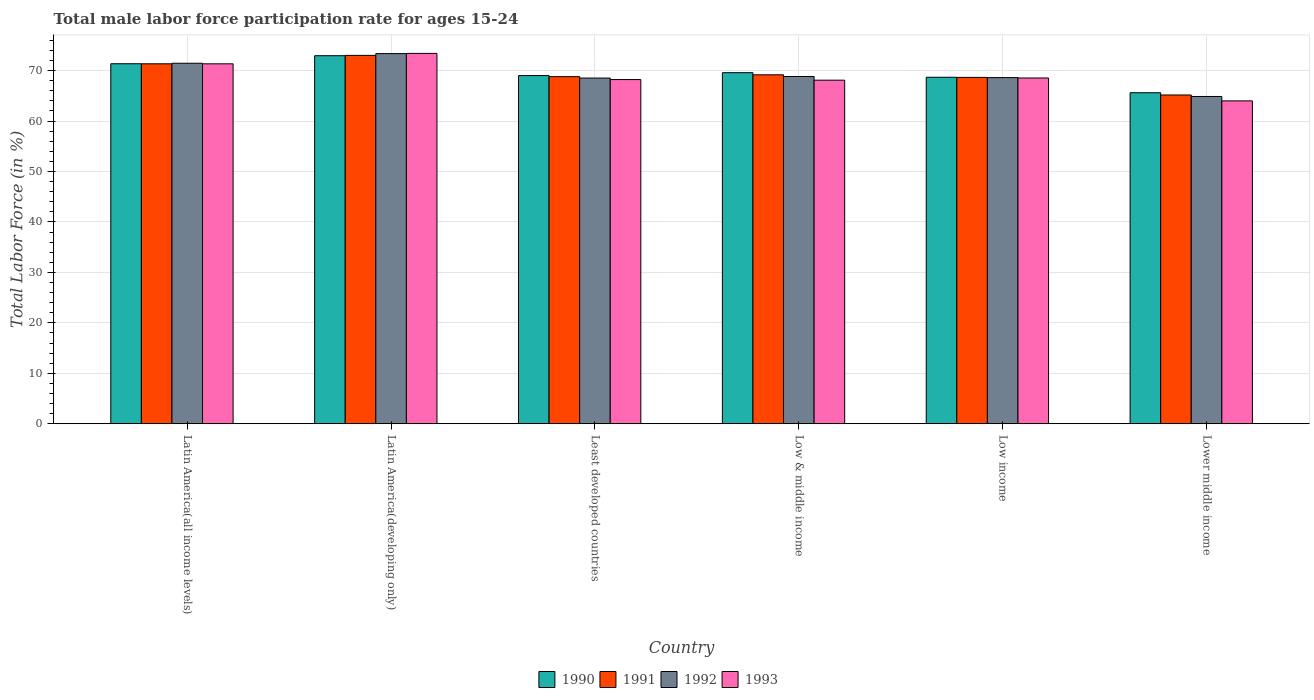How many different coloured bars are there?
Provide a succinct answer. 4. How many bars are there on the 1st tick from the right?
Give a very brief answer. 4. What is the label of the 6th group of bars from the left?
Offer a terse response. Lower middle income. In how many cases, is the number of bars for a given country not equal to the number of legend labels?
Give a very brief answer. 0. What is the male labor force participation rate in 1991 in Least developed countries?
Provide a succinct answer. 68.8. Across all countries, what is the maximum male labor force participation rate in 1992?
Provide a short and direct response. 73.38. Across all countries, what is the minimum male labor force participation rate in 1991?
Ensure brevity in your answer.  65.17. In which country was the male labor force participation rate in 1992 maximum?
Make the answer very short. Latin America(developing only). In which country was the male labor force participation rate in 1992 minimum?
Provide a succinct answer. Lower middle income. What is the total male labor force participation rate in 1992 in the graph?
Ensure brevity in your answer.  415.69. What is the difference between the male labor force participation rate in 1990 in Low & middle income and that in Low income?
Provide a succinct answer. 0.91. What is the difference between the male labor force participation rate in 1991 in Latin America(developing only) and the male labor force participation rate in 1992 in Lower middle income?
Give a very brief answer. 8.15. What is the average male labor force participation rate in 1992 per country?
Ensure brevity in your answer.  69.28. What is the difference between the male labor force participation rate of/in 1992 and male labor force participation rate of/in 1990 in Latin America(developing only)?
Your answer should be compact. 0.42. What is the ratio of the male labor force participation rate in 1993 in Latin America(all income levels) to that in Least developed countries?
Your response must be concise. 1.05. Is the male labor force participation rate in 1991 in Least developed countries less than that in Lower middle income?
Your response must be concise. No. What is the difference between the highest and the second highest male labor force participation rate in 1990?
Make the answer very short. 3.36. What is the difference between the highest and the lowest male labor force participation rate in 1990?
Ensure brevity in your answer.  7.34. Is the sum of the male labor force participation rate in 1992 in Latin America(all income levels) and Low & middle income greater than the maximum male labor force participation rate in 1993 across all countries?
Your response must be concise. Yes. What does the 2nd bar from the left in Low income represents?
Offer a terse response. 1991. How many bars are there?
Ensure brevity in your answer.  24. Are the values on the major ticks of Y-axis written in scientific E-notation?
Your answer should be very brief. No. Does the graph contain grids?
Your answer should be compact. Yes. How are the legend labels stacked?
Your response must be concise. Horizontal. What is the title of the graph?
Provide a succinct answer. Total male labor force participation rate for ages 15-24. Does "1995" appear as one of the legend labels in the graph?
Give a very brief answer. No. What is the label or title of the X-axis?
Keep it short and to the point. Country. What is the label or title of the Y-axis?
Offer a terse response. Total Labor Force (in %). What is the Total Labor Force (in %) in 1990 in Latin America(all income levels)?
Your response must be concise. 71.36. What is the Total Labor Force (in %) in 1991 in Latin America(all income levels)?
Your answer should be compact. 71.35. What is the Total Labor Force (in %) in 1992 in Latin America(all income levels)?
Provide a succinct answer. 71.46. What is the Total Labor Force (in %) in 1993 in Latin America(all income levels)?
Keep it short and to the point. 71.35. What is the Total Labor Force (in %) of 1990 in Latin America(developing only)?
Ensure brevity in your answer.  72.96. What is the Total Labor Force (in %) in 1991 in Latin America(developing only)?
Offer a very short reply. 73.02. What is the Total Labor Force (in %) in 1992 in Latin America(developing only)?
Your answer should be very brief. 73.38. What is the Total Labor Force (in %) in 1993 in Latin America(developing only)?
Offer a terse response. 73.42. What is the Total Labor Force (in %) of 1990 in Least developed countries?
Your answer should be compact. 69.02. What is the Total Labor Force (in %) in 1991 in Least developed countries?
Make the answer very short. 68.8. What is the Total Labor Force (in %) of 1992 in Least developed countries?
Your answer should be compact. 68.53. What is the Total Labor Force (in %) in 1993 in Least developed countries?
Offer a very short reply. 68.23. What is the Total Labor Force (in %) in 1990 in Low & middle income?
Your answer should be compact. 69.59. What is the Total Labor Force (in %) in 1991 in Low & middle income?
Your answer should be compact. 69.17. What is the Total Labor Force (in %) in 1992 in Low & middle income?
Keep it short and to the point. 68.83. What is the Total Labor Force (in %) of 1993 in Low & middle income?
Provide a short and direct response. 68.11. What is the Total Labor Force (in %) in 1990 in Low income?
Provide a succinct answer. 68.69. What is the Total Labor Force (in %) of 1991 in Low income?
Make the answer very short. 68.66. What is the Total Labor Force (in %) of 1992 in Low income?
Offer a very short reply. 68.62. What is the Total Labor Force (in %) in 1993 in Low income?
Offer a very short reply. 68.54. What is the Total Labor Force (in %) of 1990 in Lower middle income?
Keep it short and to the point. 65.62. What is the Total Labor Force (in %) in 1991 in Lower middle income?
Provide a succinct answer. 65.17. What is the Total Labor Force (in %) in 1992 in Lower middle income?
Make the answer very short. 64.87. What is the Total Labor Force (in %) in 1993 in Lower middle income?
Offer a terse response. 64. Across all countries, what is the maximum Total Labor Force (in %) in 1990?
Ensure brevity in your answer.  72.96. Across all countries, what is the maximum Total Labor Force (in %) of 1991?
Your response must be concise. 73.02. Across all countries, what is the maximum Total Labor Force (in %) in 1992?
Your response must be concise. 73.38. Across all countries, what is the maximum Total Labor Force (in %) of 1993?
Make the answer very short. 73.42. Across all countries, what is the minimum Total Labor Force (in %) of 1990?
Provide a succinct answer. 65.62. Across all countries, what is the minimum Total Labor Force (in %) of 1991?
Provide a short and direct response. 65.17. Across all countries, what is the minimum Total Labor Force (in %) of 1992?
Make the answer very short. 64.87. Across all countries, what is the minimum Total Labor Force (in %) of 1993?
Your response must be concise. 64. What is the total Total Labor Force (in %) of 1990 in the graph?
Keep it short and to the point. 417.24. What is the total Total Labor Force (in %) in 1991 in the graph?
Your response must be concise. 416.18. What is the total Total Labor Force (in %) in 1992 in the graph?
Your answer should be compact. 415.69. What is the total Total Labor Force (in %) of 1993 in the graph?
Your response must be concise. 413.64. What is the difference between the Total Labor Force (in %) of 1990 in Latin America(all income levels) and that in Latin America(developing only)?
Make the answer very short. -1.59. What is the difference between the Total Labor Force (in %) of 1991 in Latin America(all income levels) and that in Latin America(developing only)?
Your answer should be very brief. -1.67. What is the difference between the Total Labor Force (in %) in 1992 in Latin America(all income levels) and that in Latin America(developing only)?
Offer a very short reply. -1.91. What is the difference between the Total Labor Force (in %) in 1993 in Latin America(all income levels) and that in Latin America(developing only)?
Offer a very short reply. -2.07. What is the difference between the Total Labor Force (in %) in 1990 in Latin America(all income levels) and that in Least developed countries?
Ensure brevity in your answer.  2.35. What is the difference between the Total Labor Force (in %) of 1991 in Latin America(all income levels) and that in Least developed countries?
Your answer should be compact. 2.55. What is the difference between the Total Labor Force (in %) in 1992 in Latin America(all income levels) and that in Least developed countries?
Keep it short and to the point. 2.94. What is the difference between the Total Labor Force (in %) in 1993 in Latin America(all income levels) and that in Least developed countries?
Offer a very short reply. 3.12. What is the difference between the Total Labor Force (in %) in 1990 in Latin America(all income levels) and that in Low & middle income?
Keep it short and to the point. 1.77. What is the difference between the Total Labor Force (in %) in 1991 in Latin America(all income levels) and that in Low & middle income?
Make the answer very short. 2.18. What is the difference between the Total Labor Force (in %) in 1992 in Latin America(all income levels) and that in Low & middle income?
Give a very brief answer. 2.63. What is the difference between the Total Labor Force (in %) of 1993 in Latin America(all income levels) and that in Low & middle income?
Your answer should be compact. 3.24. What is the difference between the Total Labor Force (in %) of 1990 in Latin America(all income levels) and that in Low income?
Offer a very short reply. 2.68. What is the difference between the Total Labor Force (in %) in 1991 in Latin America(all income levels) and that in Low income?
Give a very brief answer. 2.69. What is the difference between the Total Labor Force (in %) in 1992 in Latin America(all income levels) and that in Low income?
Keep it short and to the point. 2.84. What is the difference between the Total Labor Force (in %) of 1993 in Latin America(all income levels) and that in Low income?
Ensure brevity in your answer.  2.81. What is the difference between the Total Labor Force (in %) in 1990 in Latin America(all income levels) and that in Lower middle income?
Provide a succinct answer. 5.75. What is the difference between the Total Labor Force (in %) in 1991 in Latin America(all income levels) and that in Lower middle income?
Your answer should be very brief. 6.18. What is the difference between the Total Labor Force (in %) of 1992 in Latin America(all income levels) and that in Lower middle income?
Offer a terse response. 6.59. What is the difference between the Total Labor Force (in %) of 1993 in Latin America(all income levels) and that in Lower middle income?
Your response must be concise. 7.35. What is the difference between the Total Labor Force (in %) of 1990 in Latin America(developing only) and that in Least developed countries?
Give a very brief answer. 3.94. What is the difference between the Total Labor Force (in %) in 1991 in Latin America(developing only) and that in Least developed countries?
Keep it short and to the point. 4.22. What is the difference between the Total Labor Force (in %) in 1992 in Latin America(developing only) and that in Least developed countries?
Your answer should be very brief. 4.85. What is the difference between the Total Labor Force (in %) of 1993 in Latin America(developing only) and that in Least developed countries?
Provide a short and direct response. 5.19. What is the difference between the Total Labor Force (in %) of 1990 in Latin America(developing only) and that in Low & middle income?
Your answer should be compact. 3.36. What is the difference between the Total Labor Force (in %) in 1991 in Latin America(developing only) and that in Low & middle income?
Provide a succinct answer. 3.85. What is the difference between the Total Labor Force (in %) of 1992 in Latin America(developing only) and that in Low & middle income?
Offer a terse response. 4.54. What is the difference between the Total Labor Force (in %) in 1993 in Latin America(developing only) and that in Low & middle income?
Offer a very short reply. 5.31. What is the difference between the Total Labor Force (in %) in 1990 in Latin America(developing only) and that in Low income?
Make the answer very short. 4.27. What is the difference between the Total Labor Force (in %) in 1991 in Latin America(developing only) and that in Low income?
Offer a terse response. 4.37. What is the difference between the Total Labor Force (in %) of 1992 in Latin America(developing only) and that in Low income?
Your response must be concise. 4.76. What is the difference between the Total Labor Force (in %) in 1993 in Latin America(developing only) and that in Low income?
Offer a terse response. 4.88. What is the difference between the Total Labor Force (in %) in 1990 in Latin America(developing only) and that in Lower middle income?
Offer a terse response. 7.34. What is the difference between the Total Labor Force (in %) in 1991 in Latin America(developing only) and that in Lower middle income?
Your response must be concise. 7.85. What is the difference between the Total Labor Force (in %) of 1992 in Latin America(developing only) and that in Lower middle income?
Keep it short and to the point. 8.5. What is the difference between the Total Labor Force (in %) in 1993 in Latin America(developing only) and that in Lower middle income?
Ensure brevity in your answer.  9.42. What is the difference between the Total Labor Force (in %) in 1990 in Least developed countries and that in Low & middle income?
Your response must be concise. -0.58. What is the difference between the Total Labor Force (in %) in 1991 in Least developed countries and that in Low & middle income?
Offer a very short reply. -0.37. What is the difference between the Total Labor Force (in %) of 1992 in Least developed countries and that in Low & middle income?
Your answer should be very brief. -0.31. What is the difference between the Total Labor Force (in %) in 1993 in Least developed countries and that in Low & middle income?
Ensure brevity in your answer.  0.12. What is the difference between the Total Labor Force (in %) of 1990 in Least developed countries and that in Low income?
Offer a very short reply. 0.33. What is the difference between the Total Labor Force (in %) in 1991 in Least developed countries and that in Low income?
Offer a very short reply. 0.14. What is the difference between the Total Labor Force (in %) in 1992 in Least developed countries and that in Low income?
Your answer should be very brief. -0.09. What is the difference between the Total Labor Force (in %) of 1993 in Least developed countries and that in Low income?
Offer a terse response. -0.31. What is the difference between the Total Labor Force (in %) in 1990 in Least developed countries and that in Lower middle income?
Give a very brief answer. 3.4. What is the difference between the Total Labor Force (in %) of 1991 in Least developed countries and that in Lower middle income?
Your response must be concise. 3.63. What is the difference between the Total Labor Force (in %) of 1992 in Least developed countries and that in Lower middle income?
Provide a succinct answer. 3.65. What is the difference between the Total Labor Force (in %) of 1993 in Least developed countries and that in Lower middle income?
Give a very brief answer. 4.23. What is the difference between the Total Labor Force (in %) in 1990 in Low & middle income and that in Low income?
Your answer should be very brief. 0.91. What is the difference between the Total Labor Force (in %) in 1991 in Low & middle income and that in Low income?
Offer a terse response. 0.51. What is the difference between the Total Labor Force (in %) of 1992 in Low & middle income and that in Low income?
Provide a succinct answer. 0.22. What is the difference between the Total Labor Force (in %) of 1993 in Low & middle income and that in Low income?
Offer a terse response. -0.43. What is the difference between the Total Labor Force (in %) of 1990 in Low & middle income and that in Lower middle income?
Keep it short and to the point. 3.98. What is the difference between the Total Labor Force (in %) in 1991 in Low & middle income and that in Lower middle income?
Your answer should be compact. 4. What is the difference between the Total Labor Force (in %) in 1992 in Low & middle income and that in Lower middle income?
Give a very brief answer. 3.96. What is the difference between the Total Labor Force (in %) in 1993 in Low & middle income and that in Lower middle income?
Provide a short and direct response. 4.11. What is the difference between the Total Labor Force (in %) in 1990 in Low income and that in Lower middle income?
Offer a very short reply. 3.07. What is the difference between the Total Labor Force (in %) of 1991 in Low income and that in Lower middle income?
Offer a terse response. 3.49. What is the difference between the Total Labor Force (in %) in 1992 in Low income and that in Lower middle income?
Provide a short and direct response. 3.74. What is the difference between the Total Labor Force (in %) of 1993 in Low income and that in Lower middle income?
Your answer should be compact. 4.54. What is the difference between the Total Labor Force (in %) of 1990 in Latin America(all income levels) and the Total Labor Force (in %) of 1991 in Latin America(developing only)?
Make the answer very short. -1.66. What is the difference between the Total Labor Force (in %) of 1990 in Latin America(all income levels) and the Total Labor Force (in %) of 1992 in Latin America(developing only)?
Give a very brief answer. -2.01. What is the difference between the Total Labor Force (in %) of 1990 in Latin America(all income levels) and the Total Labor Force (in %) of 1993 in Latin America(developing only)?
Ensure brevity in your answer.  -2.05. What is the difference between the Total Labor Force (in %) of 1991 in Latin America(all income levels) and the Total Labor Force (in %) of 1992 in Latin America(developing only)?
Give a very brief answer. -2.02. What is the difference between the Total Labor Force (in %) of 1991 in Latin America(all income levels) and the Total Labor Force (in %) of 1993 in Latin America(developing only)?
Offer a terse response. -2.06. What is the difference between the Total Labor Force (in %) of 1992 in Latin America(all income levels) and the Total Labor Force (in %) of 1993 in Latin America(developing only)?
Provide a succinct answer. -1.95. What is the difference between the Total Labor Force (in %) in 1990 in Latin America(all income levels) and the Total Labor Force (in %) in 1991 in Least developed countries?
Provide a short and direct response. 2.56. What is the difference between the Total Labor Force (in %) in 1990 in Latin America(all income levels) and the Total Labor Force (in %) in 1992 in Least developed countries?
Make the answer very short. 2.84. What is the difference between the Total Labor Force (in %) in 1990 in Latin America(all income levels) and the Total Labor Force (in %) in 1993 in Least developed countries?
Keep it short and to the point. 3.14. What is the difference between the Total Labor Force (in %) in 1991 in Latin America(all income levels) and the Total Labor Force (in %) in 1992 in Least developed countries?
Your answer should be very brief. 2.83. What is the difference between the Total Labor Force (in %) of 1991 in Latin America(all income levels) and the Total Labor Force (in %) of 1993 in Least developed countries?
Make the answer very short. 3.12. What is the difference between the Total Labor Force (in %) in 1992 in Latin America(all income levels) and the Total Labor Force (in %) in 1993 in Least developed countries?
Ensure brevity in your answer.  3.23. What is the difference between the Total Labor Force (in %) of 1990 in Latin America(all income levels) and the Total Labor Force (in %) of 1991 in Low & middle income?
Your response must be concise. 2.19. What is the difference between the Total Labor Force (in %) in 1990 in Latin America(all income levels) and the Total Labor Force (in %) in 1992 in Low & middle income?
Offer a terse response. 2.53. What is the difference between the Total Labor Force (in %) in 1990 in Latin America(all income levels) and the Total Labor Force (in %) in 1993 in Low & middle income?
Make the answer very short. 3.26. What is the difference between the Total Labor Force (in %) of 1991 in Latin America(all income levels) and the Total Labor Force (in %) of 1992 in Low & middle income?
Keep it short and to the point. 2.52. What is the difference between the Total Labor Force (in %) in 1991 in Latin America(all income levels) and the Total Labor Force (in %) in 1993 in Low & middle income?
Offer a very short reply. 3.25. What is the difference between the Total Labor Force (in %) of 1992 in Latin America(all income levels) and the Total Labor Force (in %) of 1993 in Low & middle income?
Give a very brief answer. 3.36. What is the difference between the Total Labor Force (in %) of 1990 in Latin America(all income levels) and the Total Labor Force (in %) of 1991 in Low income?
Give a very brief answer. 2.71. What is the difference between the Total Labor Force (in %) in 1990 in Latin America(all income levels) and the Total Labor Force (in %) in 1992 in Low income?
Give a very brief answer. 2.75. What is the difference between the Total Labor Force (in %) in 1990 in Latin America(all income levels) and the Total Labor Force (in %) in 1993 in Low income?
Make the answer very short. 2.82. What is the difference between the Total Labor Force (in %) of 1991 in Latin America(all income levels) and the Total Labor Force (in %) of 1992 in Low income?
Ensure brevity in your answer.  2.73. What is the difference between the Total Labor Force (in %) of 1991 in Latin America(all income levels) and the Total Labor Force (in %) of 1993 in Low income?
Provide a short and direct response. 2.81. What is the difference between the Total Labor Force (in %) of 1992 in Latin America(all income levels) and the Total Labor Force (in %) of 1993 in Low income?
Offer a very short reply. 2.92. What is the difference between the Total Labor Force (in %) of 1990 in Latin America(all income levels) and the Total Labor Force (in %) of 1991 in Lower middle income?
Make the answer very short. 6.19. What is the difference between the Total Labor Force (in %) in 1990 in Latin America(all income levels) and the Total Labor Force (in %) in 1992 in Lower middle income?
Ensure brevity in your answer.  6.49. What is the difference between the Total Labor Force (in %) of 1990 in Latin America(all income levels) and the Total Labor Force (in %) of 1993 in Lower middle income?
Your answer should be very brief. 7.36. What is the difference between the Total Labor Force (in %) of 1991 in Latin America(all income levels) and the Total Labor Force (in %) of 1992 in Lower middle income?
Offer a very short reply. 6.48. What is the difference between the Total Labor Force (in %) of 1991 in Latin America(all income levels) and the Total Labor Force (in %) of 1993 in Lower middle income?
Your response must be concise. 7.35. What is the difference between the Total Labor Force (in %) in 1992 in Latin America(all income levels) and the Total Labor Force (in %) in 1993 in Lower middle income?
Make the answer very short. 7.46. What is the difference between the Total Labor Force (in %) in 1990 in Latin America(developing only) and the Total Labor Force (in %) in 1991 in Least developed countries?
Make the answer very short. 4.15. What is the difference between the Total Labor Force (in %) of 1990 in Latin America(developing only) and the Total Labor Force (in %) of 1992 in Least developed countries?
Keep it short and to the point. 4.43. What is the difference between the Total Labor Force (in %) in 1990 in Latin America(developing only) and the Total Labor Force (in %) in 1993 in Least developed countries?
Your response must be concise. 4.73. What is the difference between the Total Labor Force (in %) in 1991 in Latin America(developing only) and the Total Labor Force (in %) in 1992 in Least developed countries?
Your answer should be compact. 4.5. What is the difference between the Total Labor Force (in %) of 1991 in Latin America(developing only) and the Total Labor Force (in %) of 1993 in Least developed countries?
Your answer should be very brief. 4.8. What is the difference between the Total Labor Force (in %) in 1992 in Latin America(developing only) and the Total Labor Force (in %) in 1993 in Least developed countries?
Ensure brevity in your answer.  5.15. What is the difference between the Total Labor Force (in %) in 1990 in Latin America(developing only) and the Total Labor Force (in %) in 1991 in Low & middle income?
Provide a succinct answer. 3.79. What is the difference between the Total Labor Force (in %) in 1990 in Latin America(developing only) and the Total Labor Force (in %) in 1992 in Low & middle income?
Offer a very short reply. 4.12. What is the difference between the Total Labor Force (in %) of 1990 in Latin America(developing only) and the Total Labor Force (in %) of 1993 in Low & middle income?
Provide a short and direct response. 4.85. What is the difference between the Total Labor Force (in %) of 1991 in Latin America(developing only) and the Total Labor Force (in %) of 1992 in Low & middle income?
Give a very brief answer. 4.19. What is the difference between the Total Labor Force (in %) of 1991 in Latin America(developing only) and the Total Labor Force (in %) of 1993 in Low & middle income?
Your answer should be very brief. 4.92. What is the difference between the Total Labor Force (in %) in 1992 in Latin America(developing only) and the Total Labor Force (in %) in 1993 in Low & middle income?
Give a very brief answer. 5.27. What is the difference between the Total Labor Force (in %) of 1990 in Latin America(developing only) and the Total Labor Force (in %) of 1991 in Low income?
Give a very brief answer. 4.3. What is the difference between the Total Labor Force (in %) of 1990 in Latin America(developing only) and the Total Labor Force (in %) of 1992 in Low income?
Provide a short and direct response. 4.34. What is the difference between the Total Labor Force (in %) of 1990 in Latin America(developing only) and the Total Labor Force (in %) of 1993 in Low income?
Provide a short and direct response. 4.42. What is the difference between the Total Labor Force (in %) in 1991 in Latin America(developing only) and the Total Labor Force (in %) in 1992 in Low income?
Ensure brevity in your answer.  4.4. What is the difference between the Total Labor Force (in %) of 1991 in Latin America(developing only) and the Total Labor Force (in %) of 1993 in Low income?
Keep it short and to the point. 4.48. What is the difference between the Total Labor Force (in %) in 1992 in Latin America(developing only) and the Total Labor Force (in %) in 1993 in Low income?
Offer a terse response. 4.83. What is the difference between the Total Labor Force (in %) in 1990 in Latin America(developing only) and the Total Labor Force (in %) in 1991 in Lower middle income?
Provide a succinct answer. 7.79. What is the difference between the Total Labor Force (in %) in 1990 in Latin America(developing only) and the Total Labor Force (in %) in 1992 in Lower middle income?
Give a very brief answer. 8.08. What is the difference between the Total Labor Force (in %) of 1990 in Latin America(developing only) and the Total Labor Force (in %) of 1993 in Lower middle income?
Make the answer very short. 8.96. What is the difference between the Total Labor Force (in %) of 1991 in Latin America(developing only) and the Total Labor Force (in %) of 1992 in Lower middle income?
Give a very brief answer. 8.15. What is the difference between the Total Labor Force (in %) in 1991 in Latin America(developing only) and the Total Labor Force (in %) in 1993 in Lower middle income?
Provide a short and direct response. 9.02. What is the difference between the Total Labor Force (in %) of 1992 in Latin America(developing only) and the Total Labor Force (in %) of 1993 in Lower middle income?
Provide a short and direct response. 9.37. What is the difference between the Total Labor Force (in %) of 1990 in Least developed countries and the Total Labor Force (in %) of 1991 in Low & middle income?
Your answer should be compact. -0.15. What is the difference between the Total Labor Force (in %) in 1990 in Least developed countries and the Total Labor Force (in %) in 1992 in Low & middle income?
Keep it short and to the point. 0.18. What is the difference between the Total Labor Force (in %) in 1990 in Least developed countries and the Total Labor Force (in %) in 1993 in Low & middle income?
Make the answer very short. 0.91. What is the difference between the Total Labor Force (in %) of 1991 in Least developed countries and the Total Labor Force (in %) of 1992 in Low & middle income?
Keep it short and to the point. -0.03. What is the difference between the Total Labor Force (in %) in 1991 in Least developed countries and the Total Labor Force (in %) in 1993 in Low & middle income?
Your response must be concise. 0.7. What is the difference between the Total Labor Force (in %) in 1992 in Least developed countries and the Total Labor Force (in %) in 1993 in Low & middle income?
Your response must be concise. 0.42. What is the difference between the Total Labor Force (in %) of 1990 in Least developed countries and the Total Labor Force (in %) of 1991 in Low income?
Ensure brevity in your answer.  0.36. What is the difference between the Total Labor Force (in %) of 1990 in Least developed countries and the Total Labor Force (in %) of 1992 in Low income?
Give a very brief answer. 0.4. What is the difference between the Total Labor Force (in %) in 1990 in Least developed countries and the Total Labor Force (in %) in 1993 in Low income?
Provide a succinct answer. 0.48. What is the difference between the Total Labor Force (in %) of 1991 in Least developed countries and the Total Labor Force (in %) of 1992 in Low income?
Give a very brief answer. 0.18. What is the difference between the Total Labor Force (in %) of 1991 in Least developed countries and the Total Labor Force (in %) of 1993 in Low income?
Offer a terse response. 0.26. What is the difference between the Total Labor Force (in %) in 1992 in Least developed countries and the Total Labor Force (in %) in 1993 in Low income?
Ensure brevity in your answer.  -0.01. What is the difference between the Total Labor Force (in %) of 1990 in Least developed countries and the Total Labor Force (in %) of 1991 in Lower middle income?
Ensure brevity in your answer.  3.85. What is the difference between the Total Labor Force (in %) of 1990 in Least developed countries and the Total Labor Force (in %) of 1992 in Lower middle income?
Provide a succinct answer. 4.14. What is the difference between the Total Labor Force (in %) of 1990 in Least developed countries and the Total Labor Force (in %) of 1993 in Lower middle income?
Provide a succinct answer. 5.02. What is the difference between the Total Labor Force (in %) in 1991 in Least developed countries and the Total Labor Force (in %) in 1992 in Lower middle income?
Keep it short and to the point. 3.93. What is the difference between the Total Labor Force (in %) in 1991 in Least developed countries and the Total Labor Force (in %) in 1993 in Lower middle income?
Your response must be concise. 4.8. What is the difference between the Total Labor Force (in %) in 1992 in Least developed countries and the Total Labor Force (in %) in 1993 in Lower middle income?
Give a very brief answer. 4.53. What is the difference between the Total Labor Force (in %) in 1990 in Low & middle income and the Total Labor Force (in %) in 1991 in Low income?
Ensure brevity in your answer.  0.94. What is the difference between the Total Labor Force (in %) of 1990 in Low & middle income and the Total Labor Force (in %) of 1992 in Low income?
Your response must be concise. 0.98. What is the difference between the Total Labor Force (in %) in 1990 in Low & middle income and the Total Labor Force (in %) in 1993 in Low income?
Provide a succinct answer. 1.05. What is the difference between the Total Labor Force (in %) in 1991 in Low & middle income and the Total Labor Force (in %) in 1992 in Low income?
Provide a short and direct response. 0.55. What is the difference between the Total Labor Force (in %) of 1991 in Low & middle income and the Total Labor Force (in %) of 1993 in Low income?
Provide a short and direct response. 0.63. What is the difference between the Total Labor Force (in %) in 1992 in Low & middle income and the Total Labor Force (in %) in 1993 in Low income?
Offer a terse response. 0.29. What is the difference between the Total Labor Force (in %) in 1990 in Low & middle income and the Total Labor Force (in %) in 1991 in Lower middle income?
Provide a short and direct response. 4.42. What is the difference between the Total Labor Force (in %) of 1990 in Low & middle income and the Total Labor Force (in %) of 1992 in Lower middle income?
Keep it short and to the point. 4.72. What is the difference between the Total Labor Force (in %) in 1990 in Low & middle income and the Total Labor Force (in %) in 1993 in Lower middle income?
Your response must be concise. 5.59. What is the difference between the Total Labor Force (in %) in 1991 in Low & middle income and the Total Labor Force (in %) in 1992 in Lower middle income?
Ensure brevity in your answer.  4.3. What is the difference between the Total Labor Force (in %) in 1991 in Low & middle income and the Total Labor Force (in %) in 1993 in Lower middle income?
Keep it short and to the point. 5.17. What is the difference between the Total Labor Force (in %) of 1992 in Low & middle income and the Total Labor Force (in %) of 1993 in Lower middle income?
Give a very brief answer. 4.83. What is the difference between the Total Labor Force (in %) in 1990 in Low income and the Total Labor Force (in %) in 1991 in Lower middle income?
Provide a short and direct response. 3.51. What is the difference between the Total Labor Force (in %) in 1990 in Low income and the Total Labor Force (in %) in 1992 in Lower middle income?
Ensure brevity in your answer.  3.81. What is the difference between the Total Labor Force (in %) of 1990 in Low income and the Total Labor Force (in %) of 1993 in Lower middle income?
Keep it short and to the point. 4.68. What is the difference between the Total Labor Force (in %) in 1991 in Low income and the Total Labor Force (in %) in 1992 in Lower middle income?
Your answer should be compact. 3.78. What is the difference between the Total Labor Force (in %) of 1991 in Low income and the Total Labor Force (in %) of 1993 in Lower middle income?
Your response must be concise. 4.66. What is the difference between the Total Labor Force (in %) of 1992 in Low income and the Total Labor Force (in %) of 1993 in Lower middle income?
Provide a short and direct response. 4.62. What is the average Total Labor Force (in %) of 1990 per country?
Ensure brevity in your answer.  69.54. What is the average Total Labor Force (in %) in 1991 per country?
Provide a succinct answer. 69.36. What is the average Total Labor Force (in %) in 1992 per country?
Keep it short and to the point. 69.28. What is the average Total Labor Force (in %) in 1993 per country?
Ensure brevity in your answer.  68.94. What is the difference between the Total Labor Force (in %) of 1990 and Total Labor Force (in %) of 1991 in Latin America(all income levels)?
Offer a terse response. 0.01. What is the difference between the Total Labor Force (in %) in 1990 and Total Labor Force (in %) in 1992 in Latin America(all income levels)?
Make the answer very short. -0.1. What is the difference between the Total Labor Force (in %) of 1990 and Total Labor Force (in %) of 1993 in Latin America(all income levels)?
Your answer should be very brief. 0.02. What is the difference between the Total Labor Force (in %) of 1991 and Total Labor Force (in %) of 1992 in Latin America(all income levels)?
Offer a terse response. -0.11. What is the difference between the Total Labor Force (in %) of 1991 and Total Labor Force (in %) of 1993 in Latin America(all income levels)?
Give a very brief answer. 0. What is the difference between the Total Labor Force (in %) of 1992 and Total Labor Force (in %) of 1993 in Latin America(all income levels)?
Offer a very short reply. 0.11. What is the difference between the Total Labor Force (in %) in 1990 and Total Labor Force (in %) in 1991 in Latin America(developing only)?
Ensure brevity in your answer.  -0.07. What is the difference between the Total Labor Force (in %) of 1990 and Total Labor Force (in %) of 1992 in Latin America(developing only)?
Make the answer very short. -0.42. What is the difference between the Total Labor Force (in %) of 1990 and Total Labor Force (in %) of 1993 in Latin America(developing only)?
Give a very brief answer. -0.46. What is the difference between the Total Labor Force (in %) of 1991 and Total Labor Force (in %) of 1992 in Latin America(developing only)?
Provide a succinct answer. -0.35. What is the difference between the Total Labor Force (in %) of 1991 and Total Labor Force (in %) of 1993 in Latin America(developing only)?
Make the answer very short. -0.39. What is the difference between the Total Labor Force (in %) of 1992 and Total Labor Force (in %) of 1993 in Latin America(developing only)?
Give a very brief answer. -0.04. What is the difference between the Total Labor Force (in %) in 1990 and Total Labor Force (in %) in 1991 in Least developed countries?
Provide a succinct answer. 0.21. What is the difference between the Total Labor Force (in %) of 1990 and Total Labor Force (in %) of 1992 in Least developed countries?
Provide a succinct answer. 0.49. What is the difference between the Total Labor Force (in %) in 1990 and Total Labor Force (in %) in 1993 in Least developed countries?
Offer a terse response. 0.79. What is the difference between the Total Labor Force (in %) in 1991 and Total Labor Force (in %) in 1992 in Least developed countries?
Provide a short and direct response. 0.28. What is the difference between the Total Labor Force (in %) of 1991 and Total Labor Force (in %) of 1993 in Least developed countries?
Provide a short and direct response. 0.57. What is the difference between the Total Labor Force (in %) of 1992 and Total Labor Force (in %) of 1993 in Least developed countries?
Provide a succinct answer. 0.3. What is the difference between the Total Labor Force (in %) in 1990 and Total Labor Force (in %) in 1991 in Low & middle income?
Offer a very short reply. 0.42. What is the difference between the Total Labor Force (in %) in 1990 and Total Labor Force (in %) in 1992 in Low & middle income?
Make the answer very short. 0.76. What is the difference between the Total Labor Force (in %) in 1990 and Total Labor Force (in %) in 1993 in Low & middle income?
Offer a terse response. 1.49. What is the difference between the Total Labor Force (in %) of 1991 and Total Labor Force (in %) of 1992 in Low & middle income?
Keep it short and to the point. 0.34. What is the difference between the Total Labor Force (in %) of 1991 and Total Labor Force (in %) of 1993 in Low & middle income?
Offer a terse response. 1.06. What is the difference between the Total Labor Force (in %) of 1992 and Total Labor Force (in %) of 1993 in Low & middle income?
Your response must be concise. 0.73. What is the difference between the Total Labor Force (in %) in 1990 and Total Labor Force (in %) in 1991 in Low income?
Provide a succinct answer. 0.03. What is the difference between the Total Labor Force (in %) of 1990 and Total Labor Force (in %) of 1992 in Low income?
Your answer should be compact. 0.07. What is the difference between the Total Labor Force (in %) of 1990 and Total Labor Force (in %) of 1993 in Low income?
Keep it short and to the point. 0.14. What is the difference between the Total Labor Force (in %) of 1991 and Total Labor Force (in %) of 1992 in Low income?
Your answer should be very brief. 0.04. What is the difference between the Total Labor Force (in %) in 1991 and Total Labor Force (in %) in 1993 in Low income?
Your answer should be compact. 0.12. What is the difference between the Total Labor Force (in %) in 1992 and Total Labor Force (in %) in 1993 in Low income?
Give a very brief answer. 0.08. What is the difference between the Total Labor Force (in %) in 1990 and Total Labor Force (in %) in 1991 in Lower middle income?
Offer a very short reply. 0.45. What is the difference between the Total Labor Force (in %) in 1990 and Total Labor Force (in %) in 1992 in Lower middle income?
Your response must be concise. 0.74. What is the difference between the Total Labor Force (in %) of 1990 and Total Labor Force (in %) of 1993 in Lower middle income?
Your answer should be compact. 1.62. What is the difference between the Total Labor Force (in %) in 1991 and Total Labor Force (in %) in 1992 in Lower middle income?
Provide a succinct answer. 0.3. What is the difference between the Total Labor Force (in %) in 1991 and Total Labor Force (in %) in 1993 in Lower middle income?
Your answer should be compact. 1.17. What is the difference between the Total Labor Force (in %) in 1992 and Total Labor Force (in %) in 1993 in Lower middle income?
Your answer should be compact. 0.87. What is the ratio of the Total Labor Force (in %) in 1990 in Latin America(all income levels) to that in Latin America(developing only)?
Make the answer very short. 0.98. What is the ratio of the Total Labor Force (in %) in 1991 in Latin America(all income levels) to that in Latin America(developing only)?
Provide a succinct answer. 0.98. What is the ratio of the Total Labor Force (in %) of 1992 in Latin America(all income levels) to that in Latin America(developing only)?
Your answer should be compact. 0.97. What is the ratio of the Total Labor Force (in %) in 1993 in Latin America(all income levels) to that in Latin America(developing only)?
Give a very brief answer. 0.97. What is the ratio of the Total Labor Force (in %) in 1990 in Latin America(all income levels) to that in Least developed countries?
Ensure brevity in your answer.  1.03. What is the ratio of the Total Labor Force (in %) in 1991 in Latin America(all income levels) to that in Least developed countries?
Your answer should be compact. 1.04. What is the ratio of the Total Labor Force (in %) of 1992 in Latin America(all income levels) to that in Least developed countries?
Ensure brevity in your answer.  1.04. What is the ratio of the Total Labor Force (in %) in 1993 in Latin America(all income levels) to that in Least developed countries?
Your answer should be compact. 1.05. What is the ratio of the Total Labor Force (in %) of 1990 in Latin America(all income levels) to that in Low & middle income?
Offer a terse response. 1.03. What is the ratio of the Total Labor Force (in %) in 1991 in Latin America(all income levels) to that in Low & middle income?
Make the answer very short. 1.03. What is the ratio of the Total Labor Force (in %) of 1992 in Latin America(all income levels) to that in Low & middle income?
Ensure brevity in your answer.  1.04. What is the ratio of the Total Labor Force (in %) in 1993 in Latin America(all income levels) to that in Low & middle income?
Your response must be concise. 1.05. What is the ratio of the Total Labor Force (in %) of 1990 in Latin America(all income levels) to that in Low income?
Keep it short and to the point. 1.04. What is the ratio of the Total Labor Force (in %) in 1991 in Latin America(all income levels) to that in Low income?
Keep it short and to the point. 1.04. What is the ratio of the Total Labor Force (in %) of 1992 in Latin America(all income levels) to that in Low income?
Offer a very short reply. 1.04. What is the ratio of the Total Labor Force (in %) of 1993 in Latin America(all income levels) to that in Low income?
Make the answer very short. 1.04. What is the ratio of the Total Labor Force (in %) of 1990 in Latin America(all income levels) to that in Lower middle income?
Offer a very short reply. 1.09. What is the ratio of the Total Labor Force (in %) in 1991 in Latin America(all income levels) to that in Lower middle income?
Offer a terse response. 1.09. What is the ratio of the Total Labor Force (in %) of 1992 in Latin America(all income levels) to that in Lower middle income?
Ensure brevity in your answer.  1.1. What is the ratio of the Total Labor Force (in %) in 1993 in Latin America(all income levels) to that in Lower middle income?
Your answer should be compact. 1.11. What is the ratio of the Total Labor Force (in %) in 1990 in Latin America(developing only) to that in Least developed countries?
Your answer should be very brief. 1.06. What is the ratio of the Total Labor Force (in %) in 1991 in Latin America(developing only) to that in Least developed countries?
Ensure brevity in your answer.  1.06. What is the ratio of the Total Labor Force (in %) in 1992 in Latin America(developing only) to that in Least developed countries?
Provide a short and direct response. 1.07. What is the ratio of the Total Labor Force (in %) in 1993 in Latin America(developing only) to that in Least developed countries?
Your answer should be compact. 1.08. What is the ratio of the Total Labor Force (in %) in 1990 in Latin America(developing only) to that in Low & middle income?
Make the answer very short. 1.05. What is the ratio of the Total Labor Force (in %) of 1991 in Latin America(developing only) to that in Low & middle income?
Your response must be concise. 1.06. What is the ratio of the Total Labor Force (in %) in 1992 in Latin America(developing only) to that in Low & middle income?
Offer a very short reply. 1.07. What is the ratio of the Total Labor Force (in %) of 1993 in Latin America(developing only) to that in Low & middle income?
Provide a succinct answer. 1.08. What is the ratio of the Total Labor Force (in %) in 1990 in Latin America(developing only) to that in Low income?
Your answer should be very brief. 1.06. What is the ratio of the Total Labor Force (in %) in 1991 in Latin America(developing only) to that in Low income?
Provide a succinct answer. 1.06. What is the ratio of the Total Labor Force (in %) of 1992 in Latin America(developing only) to that in Low income?
Make the answer very short. 1.07. What is the ratio of the Total Labor Force (in %) of 1993 in Latin America(developing only) to that in Low income?
Your response must be concise. 1.07. What is the ratio of the Total Labor Force (in %) in 1990 in Latin America(developing only) to that in Lower middle income?
Offer a very short reply. 1.11. What is the ratio of the Total Labor Force (in %) in 1991 in Latin America(developing only) to that in Lower middle income?
Provide a short and direct response. 1.12. What is the ratio of the Total Labor Force (in %) of 1992 in Latin America(developing only) to that in Lower middle income?
Provide a short and direct response. 1.13. What is the ratio of the Total Labor Force (in %) in 1993 in Latin America(developing only) to that in Lower middle income?
Give a very brief answer. 1.15. What is the ratio of the Total Labor Force (in %) in 1990 in Least developed countries to that in Low & middle income?
Your answer should be compact. 0.99. What is the ratio of the Total Labor Force (in %) in 1991 in Least developed countries to that in Low & middle income?
Give a very brief answer. 0.99. What is the ratio of the Total Labor Force (in %) of 1992 in Least developed countries to that in Low & middle income?
Give a very brief answer. 1. What is the ratio of the Total Labor Force (in %) in 1993 in Least developed countries to that in Low & middle income?
Offer a terse response. 1. What is the ratio of the Total Labor Force (in %) in 1990 in Least developed countries to that in Low income?
Provide a short and direct response. 1. What is the ratio of the Total Labor Force (in %) of 1991 in Least developed countries to that in Low income?
Your answer should be compact. 1. What is the ratio of the Total Labor Force (in %) in 1992 in Least developed countries to that in Low income?
Your answer should be compact. 1. What is the ratio of the Total Labor Force (in %) in 1990 in Least developed countries to that in Lower middle income?
Provide a short and direct response. 1.05. What is the ratio of the Total Labor Force (in %) of 1991 in Least developed countries to that in Lower middle income?
Give a very brief answer. 1.06. What is the ratio of the Total Labor Force (in %) in 1992 in Least developed countries to that in Lower middle income?
Make the answer very short. 1.06. What is the ratio of the Total Labor Force (in %) in 1993 in Least developed countries to that in Lower middle income?
Keep it short and to the point. 1.07. What is the ratio of the Total Labor Force (in %) in 1990 in Low & middle income to that in Low income?
Your response must be concise. 1.01. What is the ratio of the Total Labor Force (in %) of 1991 in Low & middle income to that in Low income?
Keep it short and to the point. 1.01. What is the ratio of the Total Labor Force (in %) of 1992 in Low & middle income to that in Low income?
Your answer should be very brief. 1. What is the ratio of the Total Labor Force (in %) of 1990 in Low & middle income to that in Lower middle income?
Offer a very short reply. 1.06. What is the ratio of the Total Labor Force (in %) in 1991 in Low & middle income to that in Lower middle income?
Provide a short and direct response. 1.06. What is the ratio of the Total Labor Force (in %) in 1992 in Low & middle income to that in Lower middle income?
Offer a very short reply. 1.06. What is the ratio of the Total Labor Force (in %) in 1993 in Low & middle income to that in Lower middle income?
Give a very brief answer. 1.06. What is the ratio of the Total Labor Force (in %) in 1990 in Low income to that in Lower middle income?
Your answer should be compact. 1.05. What is the ratio of the Total Labor Force (in %) of 1991 in Low income to that in Lower middle income?
Give a very brief answer. 1.05. What is the ratio of the Total Labor Force (in %) of 1992 in Low income to that in Lower middle income?
Provide a short and direct response. 1.06. What is the ratio of the Total Labor Force (in %) of 1993 in Low income to that in Lower middle income?
Your answer should be very brief. 1.07. What is the difference between the highest and the second highest Total Labor Force (in %) of 1990?
Keep it short and to the point. 1.59. What is the difference between the highest and the second highest Total Labor Force (in %) in 1991?
Offer a terse response. 1.67. What is the difference between the highest and the second highest Total Labor Force (in %) in 1992?
Your answer should be very brief. 1.91. What is the difference between the highest and the second highest Total Labor Force (in %) in 1993?
Your answer should be compact. 2.07. What is the difference between the highest and the lowest Total Labor Force (in %) of 1990?
Your response must be concise. 7.34. What is the difference between the highest and the lowest Total Labor Force (in %) in 1991?
Your response must be concise. 7.85. What is the difference between the highest and the lowest Total Labor Force (in %) of 1992?
Provide a succinct answer. 8.5. What is the difference between the highest and the lowest Total Labor Force (in %) of 1993?
Your answer should be very brief. 9.42. 